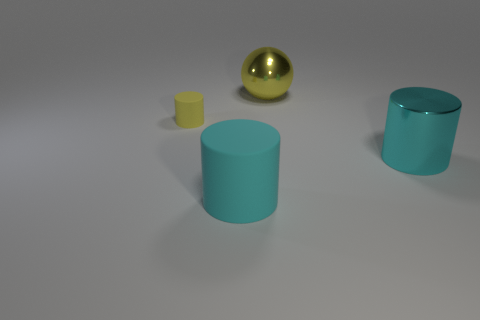There is a small cylinder that is to the left of the large metallic thing in front of the small yellow thing; what is its material? The material of the small cylinder appears to be matte plastic, based on the absence of any reflective properties and its visible texture that is typical for such materials. 